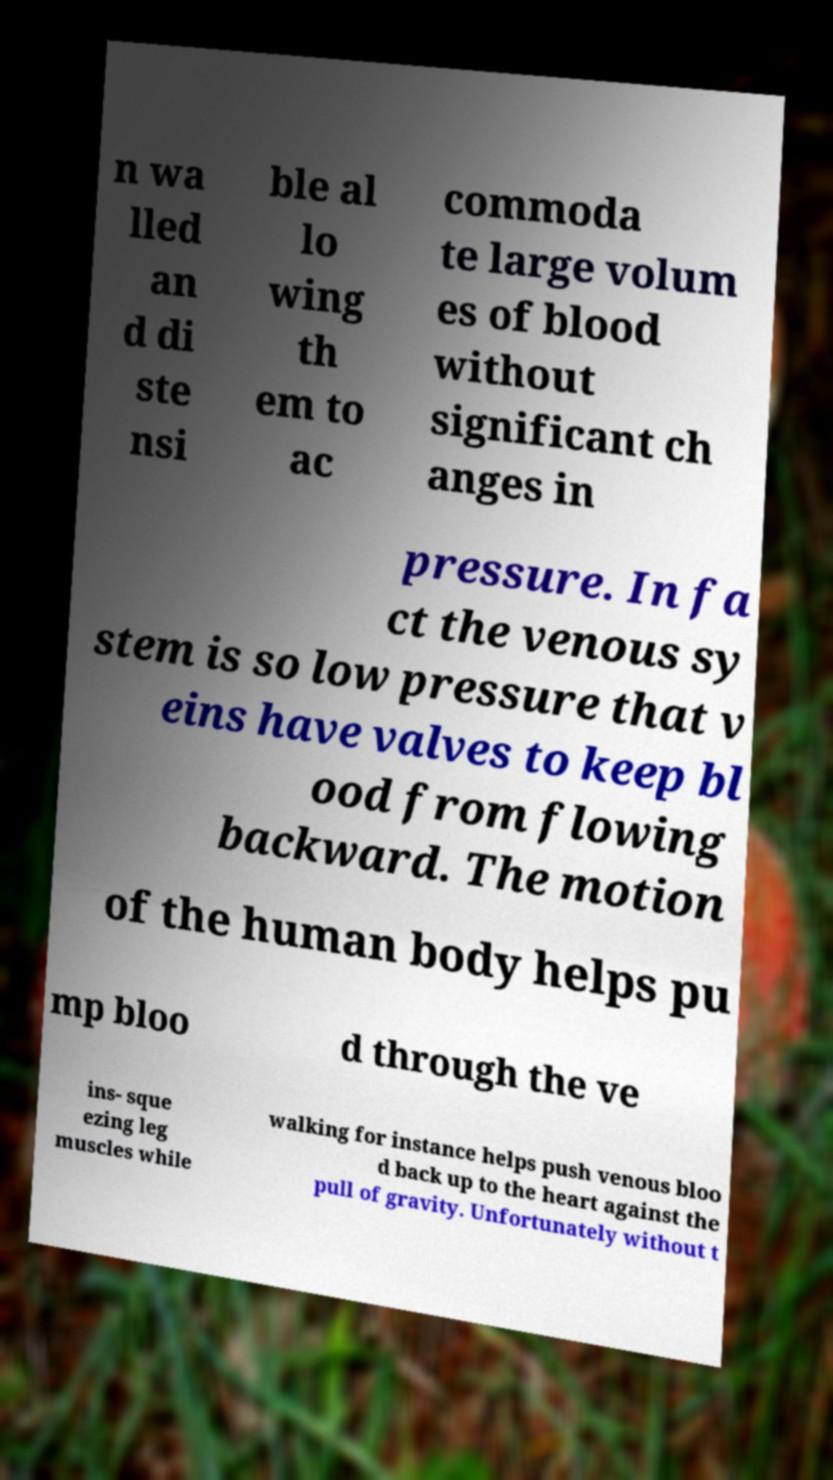For documentation purposes, I need the text within this image transcribed. Could you provide that? n wa lled an d di ste nsi ble al lo wing th em to ac commoda te large volum es of blood without significant ch anges in pressure. In fa ct the venous sy stem is so low pressure that v eins have valves to keep bl ood from flowing backward. The motion of the human body helps pu mp bloo d through the ve ins- sque ezing leg muscles while walking for instance helps push venous bloo d back up to the heart against the pull of gravity. Unfortunately without t 